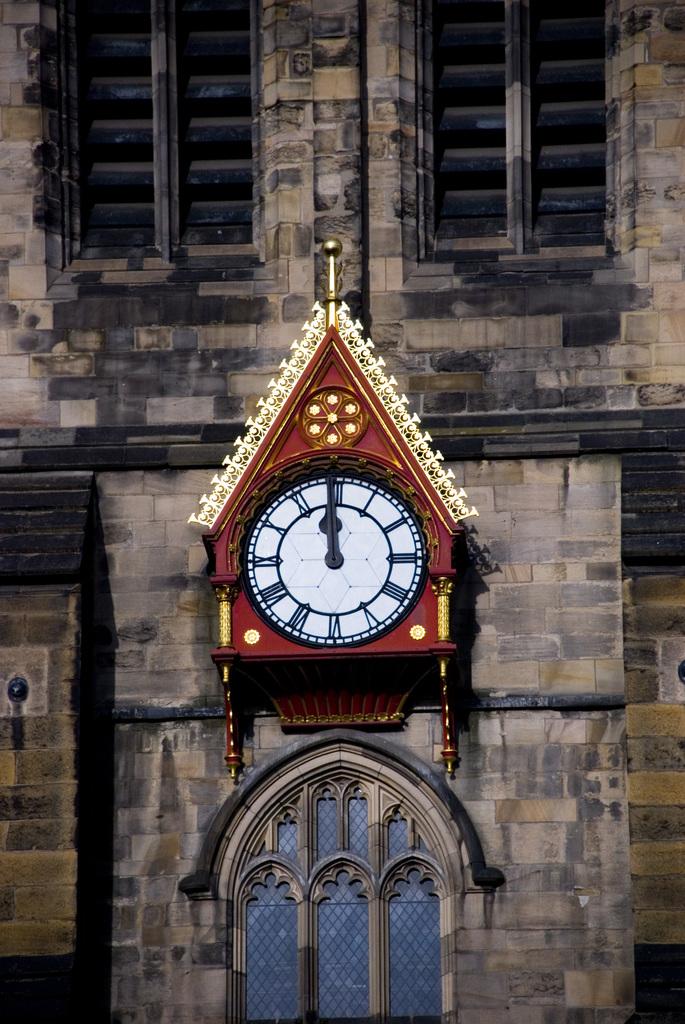What time is it?
Keep it short and to the point. 12:00. Is a brand name shown?
Offer a terse response. No. 